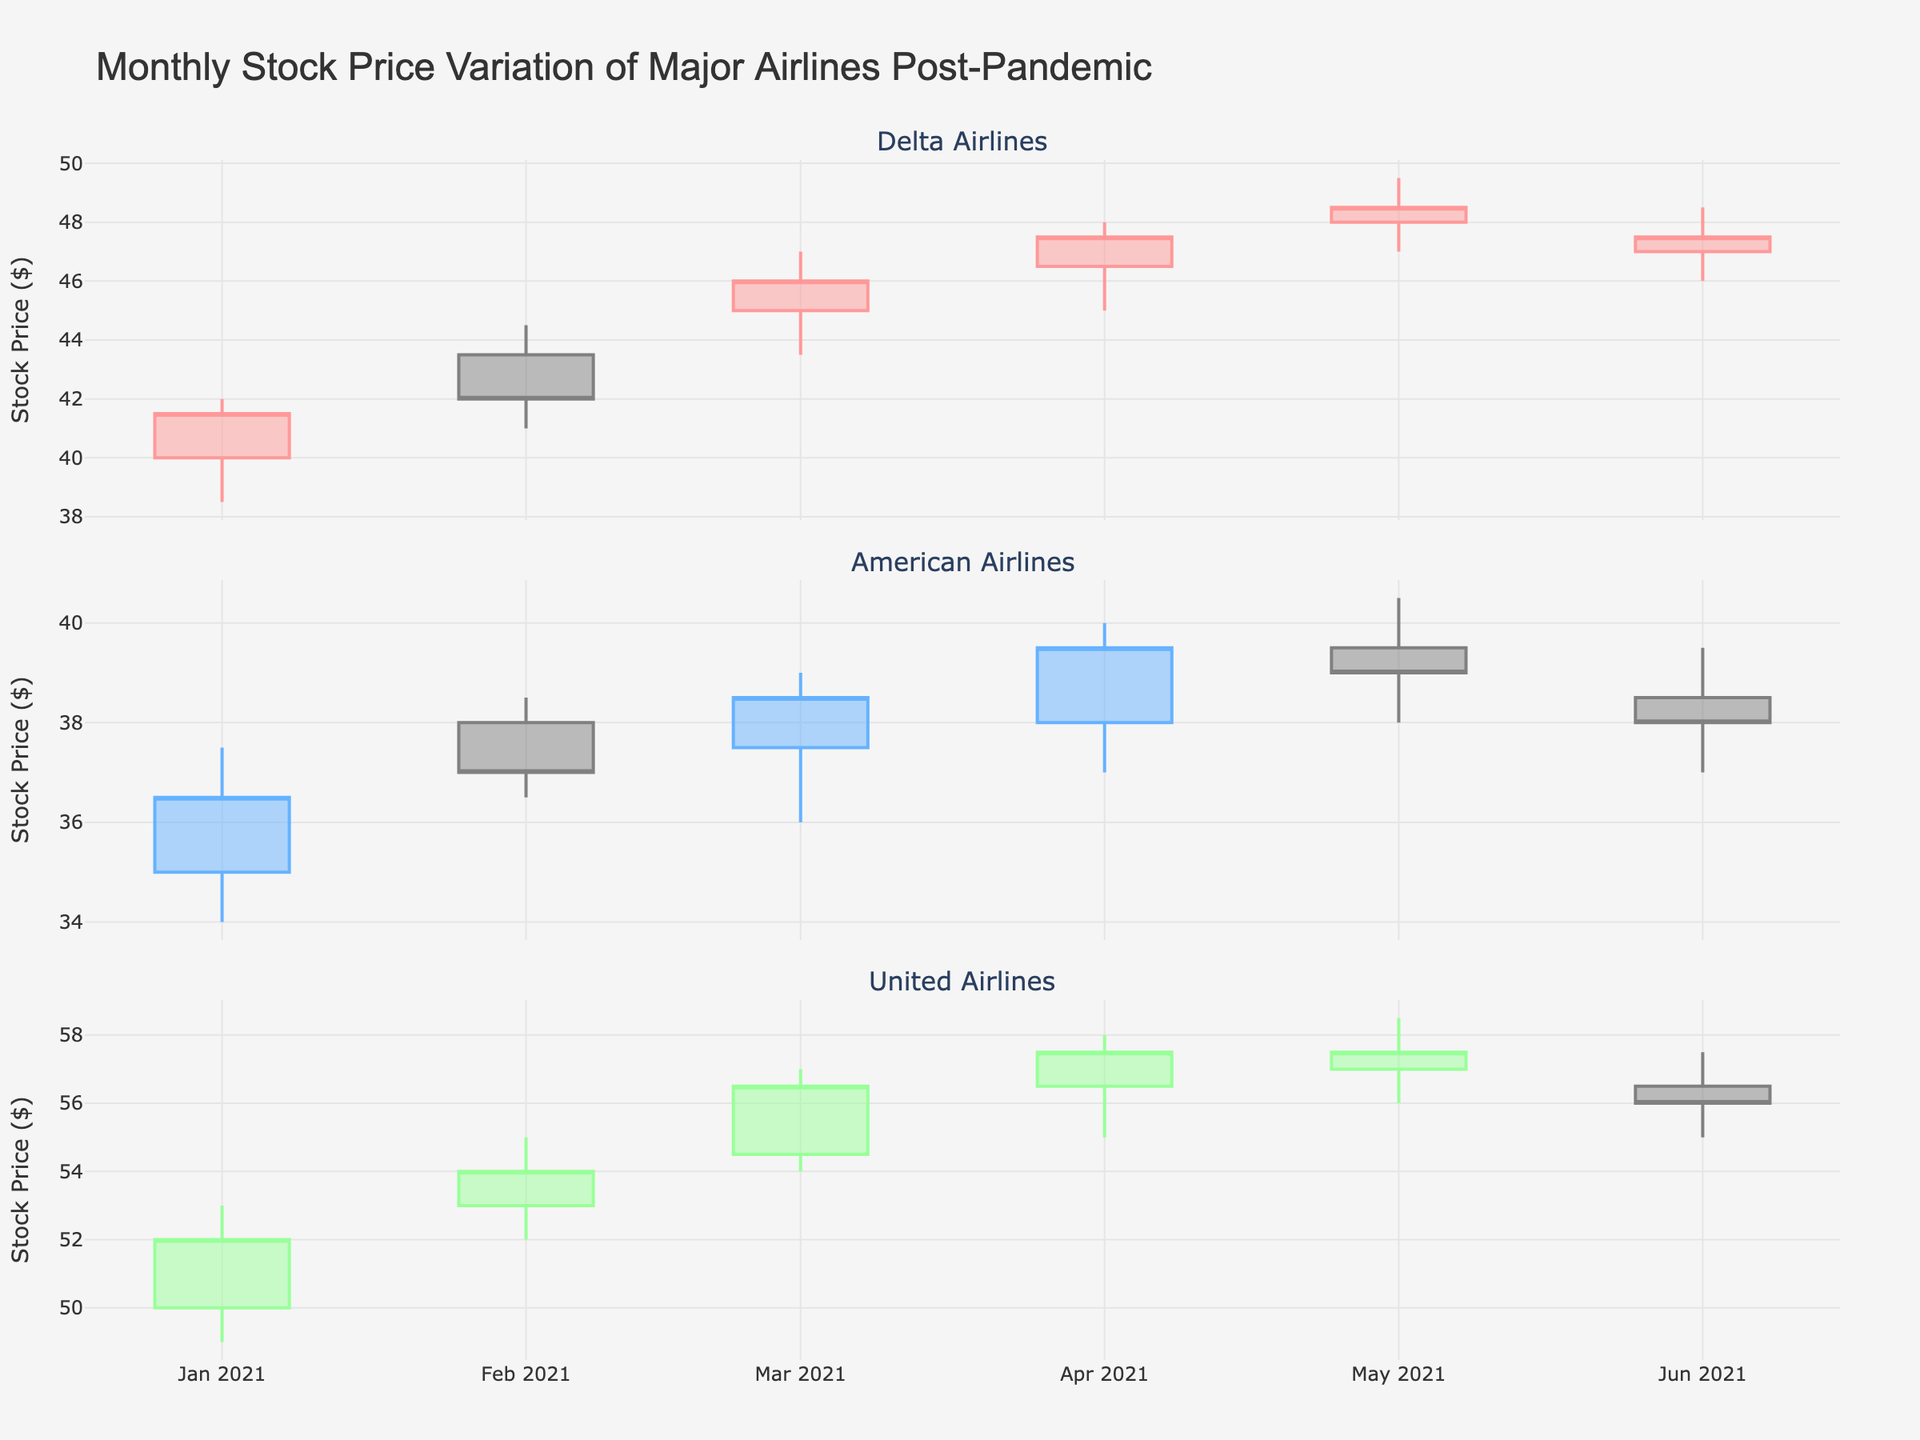What's the title of the chart? The title of the chart is located at the top and reads "Monthly Stock Price Variation of Major Airlines Post-Pandemic".
Answer: Monthly Stock Price Variation of Major Airlines Post-Pandemic What are the three airlines represented in the chart? There are three distinct subplots, each representing one airline. The subplot titles state "Delta Airlines", "American Airlines", and "United Airlines".
Answer: Delta Airlines, American Airlines, United Airlines Which airline had the highest closing price in March 2021? In the March 2021 subplot, the closing prices are at the top of each candlestick. For United Airlines, the closing price is higher than the other two airlines.
Answer: United Airlines What is the general trend for Delta Airlines from January to June 2021? By observing the progression of candlesticks from January to June 2021 in the Delta Airlines subplot, the stock price shows a general upward trend.
Answer: Upward trend How does the closing stock price of American Airlines in June 2021 compare to May 2021? In the American Airlines subplot, the closing price for June 2021 is indicated by the right end of the candlestick body. Comparing these values for May and June shows a decrease.
Answer: Lower in June 2021 Which month had the highest volatility for United Airlines, and how can you tell? Volatility is indicated by the length of the candlestick wicks. In April 2021, the wicks for United Airlines are longest, suggesting the highest volatility.
Answer: April 2021 What's the average closing price for Delta Airlines across all months shown? To find the average closing price for Delta Airlines, sum the closing prices for each month and divide by the number of months ((41.5 + 42.0 + 46.0 + 47.5 + 48.5 + 47.5) / 6). This equals 273 / 6.
Answer: 45.5 In which month did American Airlines have the smallest range between its highest and lowest prices? The smallest range is indicated by the shortest candlestick body. For American Airlines, this appears in February 2021.
Answer: February 2021 Compare the volumes traded for the three airlines in January 2021. Which airline had the highest volume? The volume for each airline is listed in the respective candlesticks' data. Delta Airlines had a volume of 1,000,000, American Airlines had 950,000, and United Airlines had 850,000.
Answer: Delta Airlines 